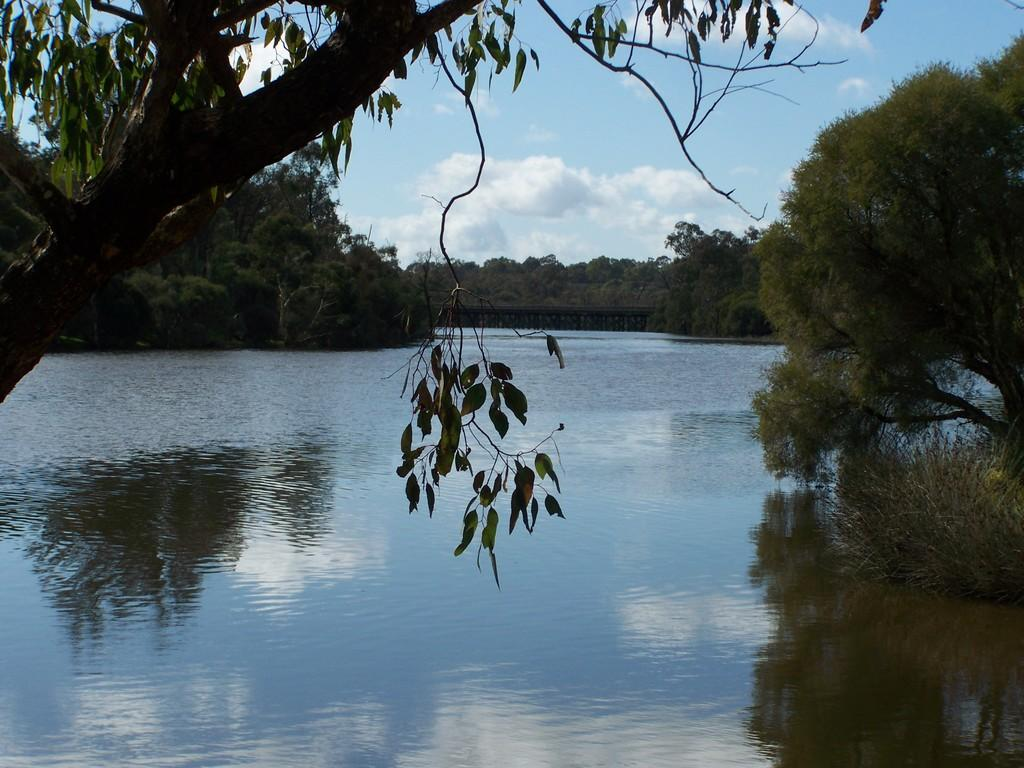What type of vegetation can be seen in the image? There are trees in the image. What natural element is visible in the image besides trees? There is water visible in the image. What part of the sky is visible in the image? The sky is visible in the image. What can be observed in the sky in the image? Clouds are present in the image. Can you see a cactus in the image? There is no cactus present in the image. How many bees are buzzing around the trees in the image? There are no bees visible in the image. 